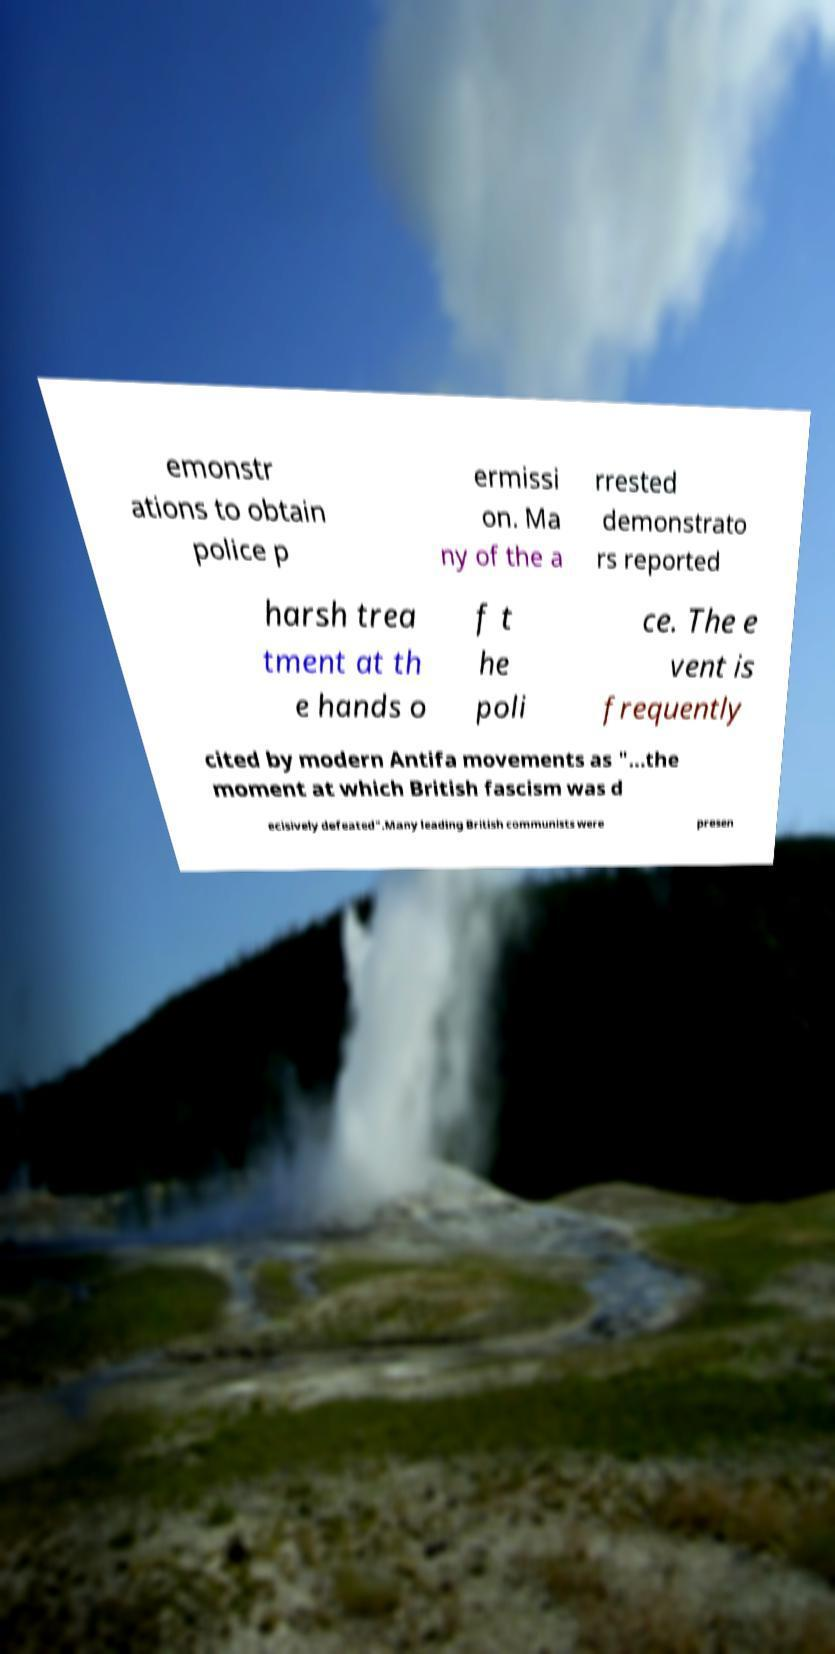There's text embedded in this image that I need extracted. Can you transcribe it verbatim? emonstr ations to obtain police p ermissi on. Ma ny of the a rrested demonstrato rs reported harsh trea tment at th e hands o f t he poli ce. The e vent is frequently cited by modern Antifa movements as "...the moment at which British fascism was d ecisively defeated".Many leading British communists were presen 